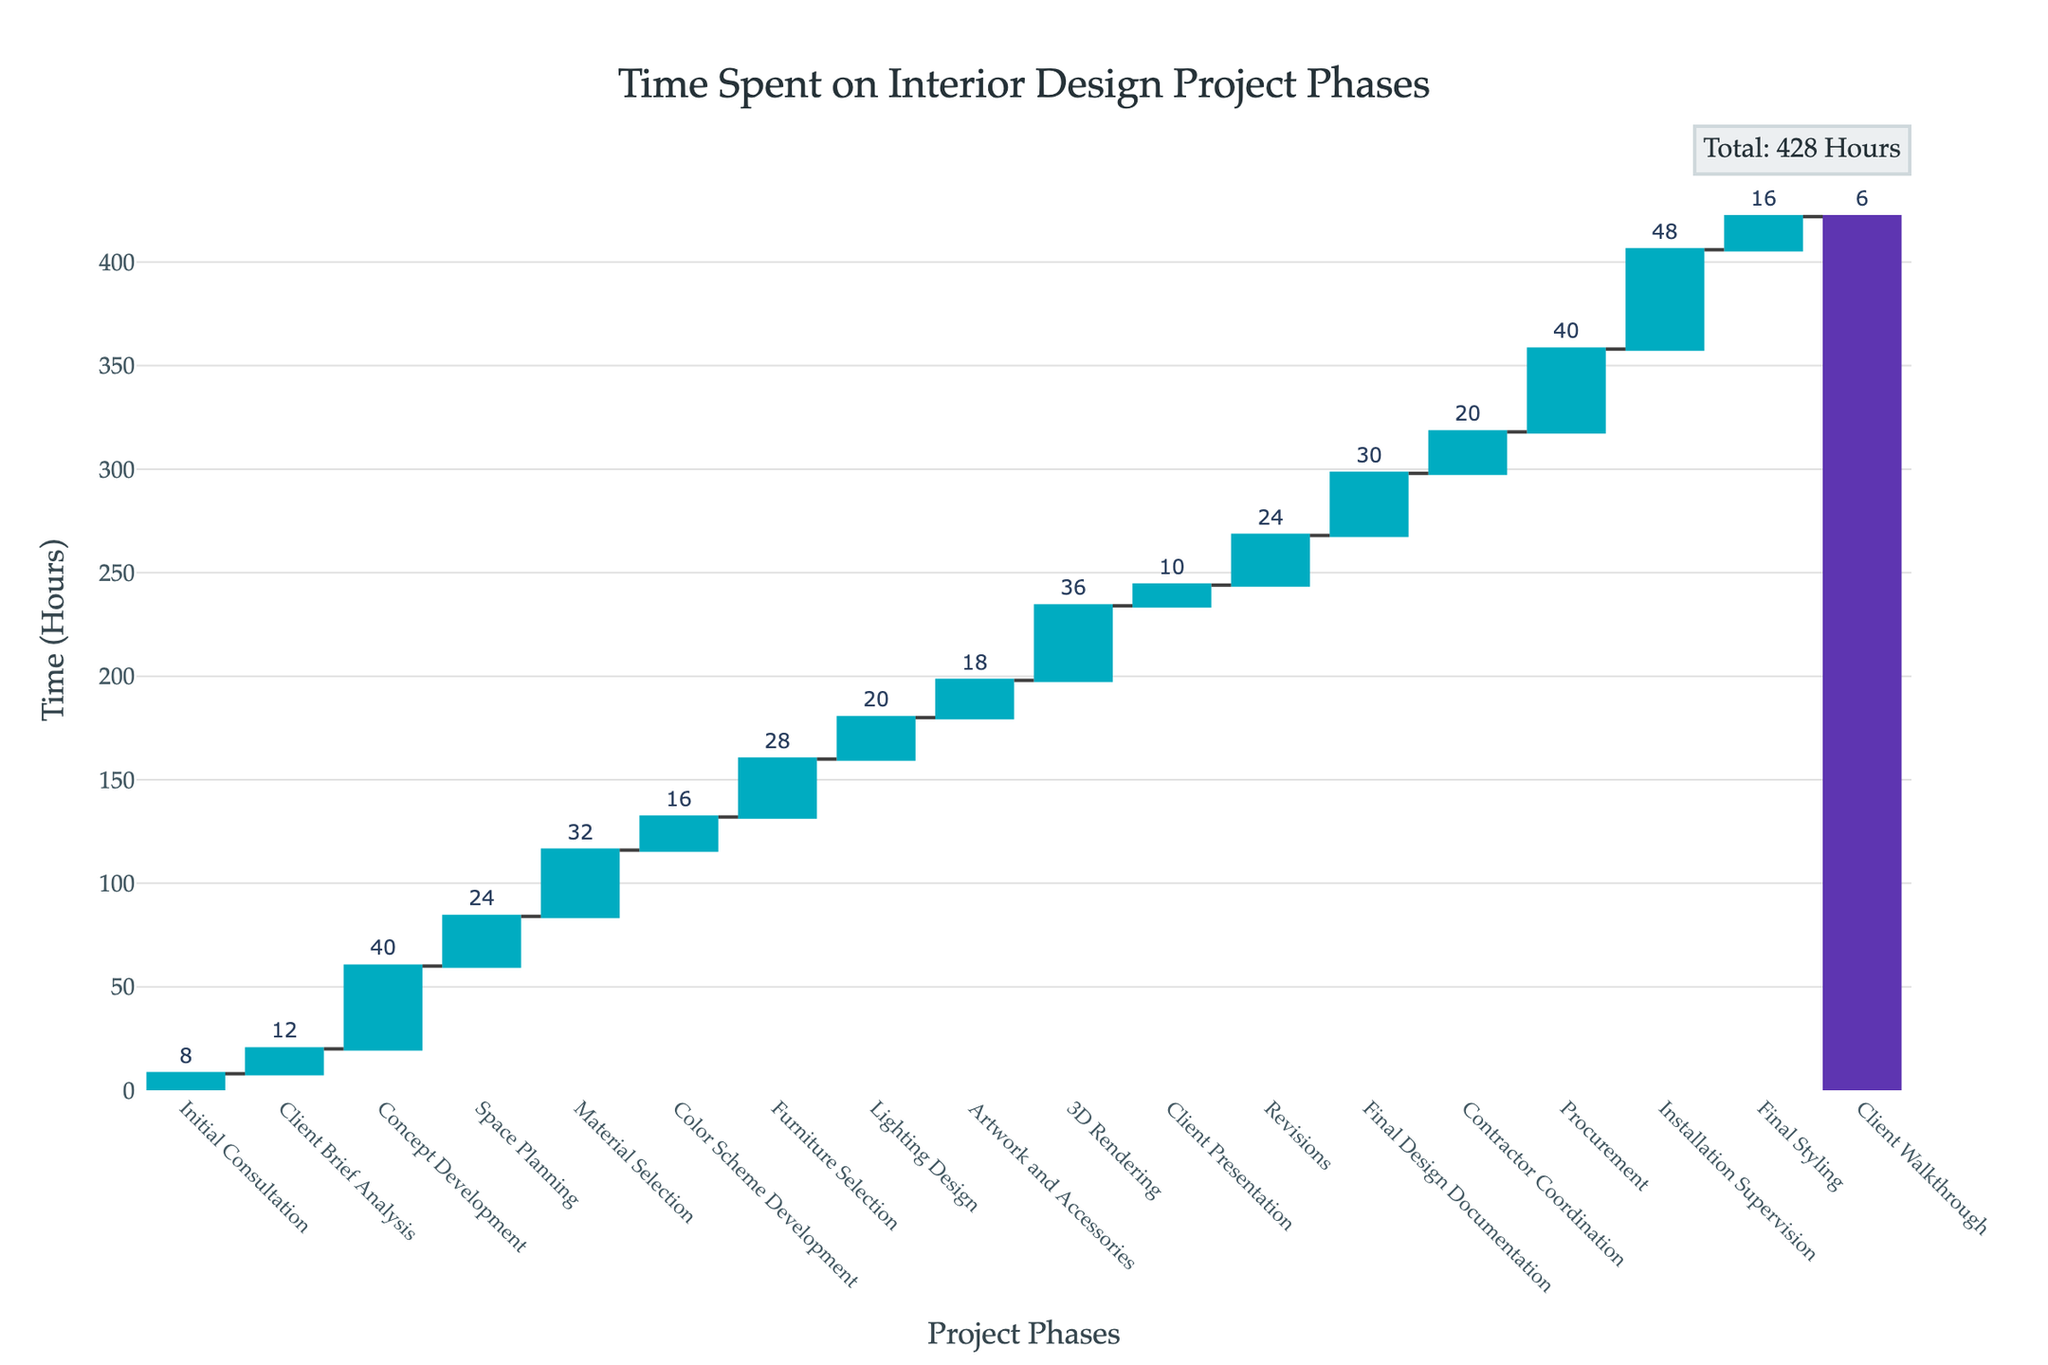What is the total time spent on the entire interior design project? The sum of all the hours spent on each phase is indicated on the figure. According to the annotation, the total is displayed in the upper right corner of the plot.
Answer: 430 hours How many phases took more than 30 hours? By examining the Waterfall Chart, we can count the bars that exceed the 30-hour mark. They are Concept Development, Material Selection, 3D Rendering, Procurement, and Installation Supervision.
Answer: 5 phases Which phase took the longest time? The phase with the highest bar represents the longest time spent. The highest bar in the chart is for Installation Supervision.
Answer: Installation Supervision How much time was spent on Concept Development compared to Space Planning? Look at the bars corresponding to Concept Development and Space Planning. Concept Development took 40 hours and Space Planning took 24 hours. To compare, subtract 24 from 40.
Answer: 16 hours more What is the total time spent on Installation Supervision, Final Styling, and Client Walkthrough together? Sum the hours for these three phases: Installation Supervision (48 hours), Final Styling (16 hours), and Client Walkthrough (6 hours). Adding these together gives 48 + 16 + 6 = 70 hours.
Answer: 70 hours Which phase took less time: Initial Consultation or Client Walkthrough? Compare the bars for Initial Consultation and Client Walkthrough. Initial Consultation took 8 hours, and Client Walkthrough took 6 hours.
Answer: Client Walkthrough How much time difference is there between the time spent on Artwork and Accessories and Lighting Design? Observe both bars for Artwork and Accessories (18 hours) and Lighting Design (20 hours). Subtract 18 from 20.
Answer: 2 hours What phase accounts for the transition from the concept to more specific designs, based on time spent? Compare the phases and look for the one that comes after Concept Development and marks the start of detailed planning. This phase is Space Planning as it transitions from Concept Development to more specific designs in the project.
Answer: Space Planning Which phases marked significant increases in total project time? Identify bars that lead to significant jumps in the cumulative sum. Phases such as Concept Development, 3D Rendering, and Installation Supervision show noticeable increases.
Answer: Concept Development, 3D Rendering, Installation Supervision What is the average time spent on each phase of the project? Calculate the average by dividing the total time by the number of phases. There are 18 phases and the total time is 430 hours. So, the average time per phase is 430 / 18 ≈ 23.89 hours.
Answer: Approximately 23.89 hours 